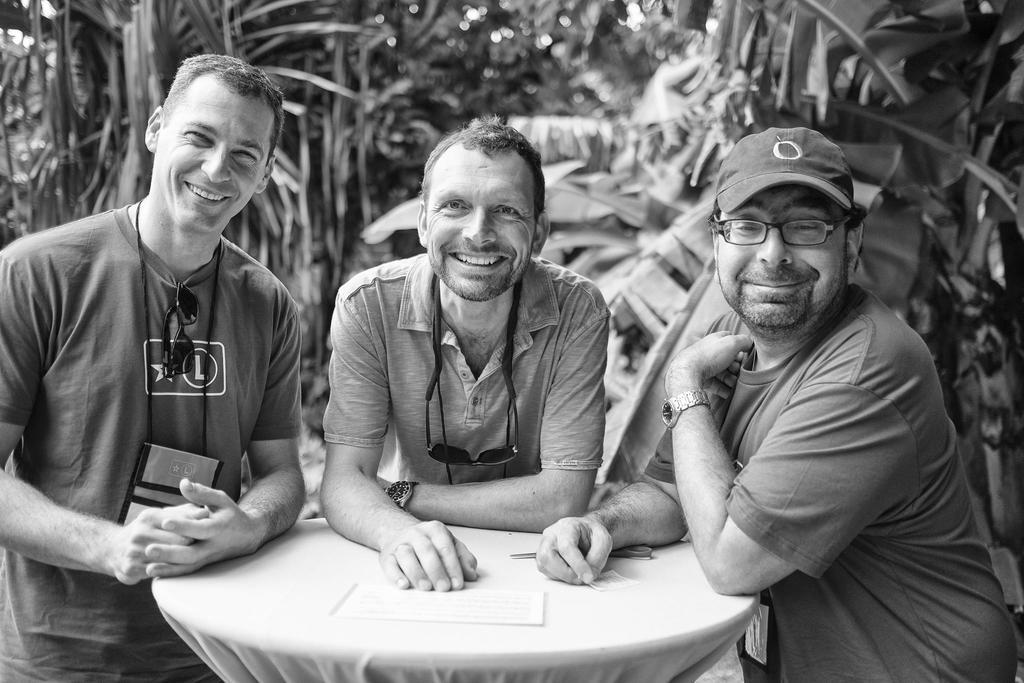How many people are in the image? There are three people standing in the image. What are the people doing in the image? The people are smiling. What is on the table in the image? There is a table in the image}. What is on the table in the image? There is a paper and scissors on the table. What can be seen in the background of the image? There are trees in the background of the image. What flavor of ice cream is the son eating in the image? There is no son or ice cream present in the image. What type of tub is visible in the image? There is no tub present in the image. 